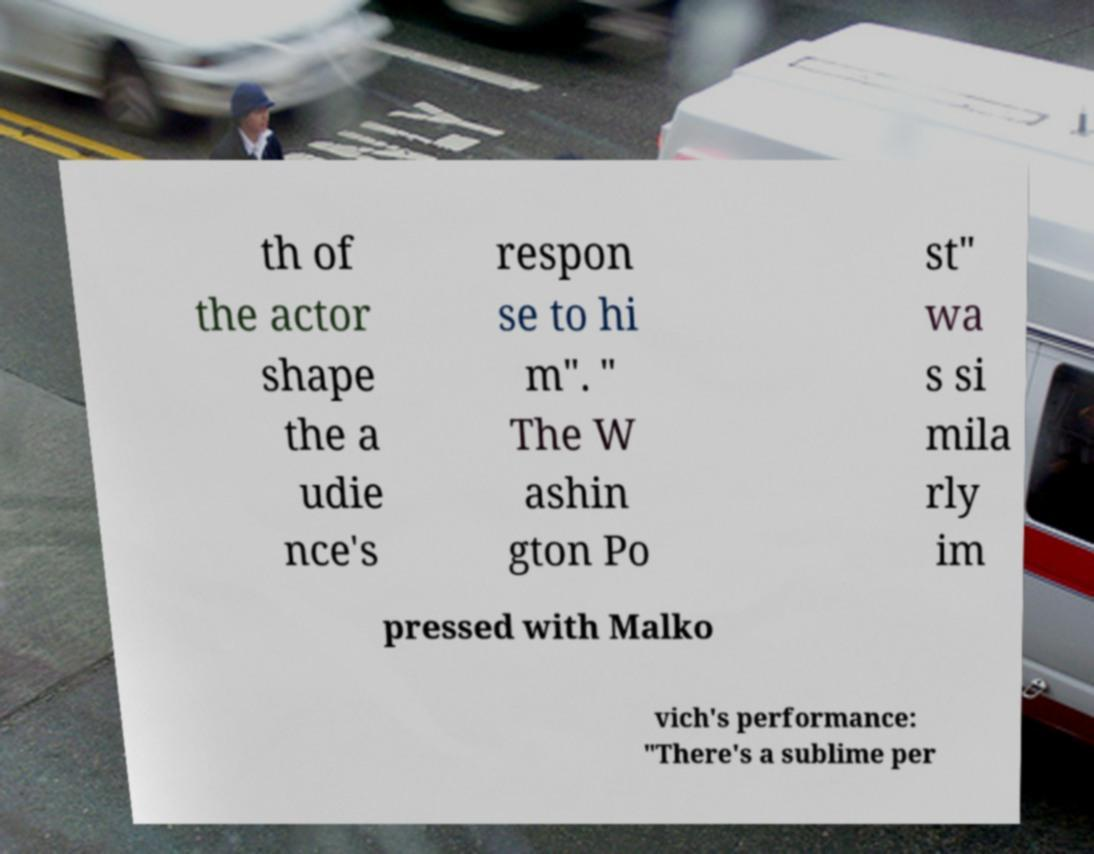There's text embedded in this image that I need extracted. Can you transcribe it verbatim? th of the actor shape the a udie nce's respon se to hi m". " The W ashin gton Po st" wa s si mila rly im pressed with Malko vich's performance: "There's a sublime per 